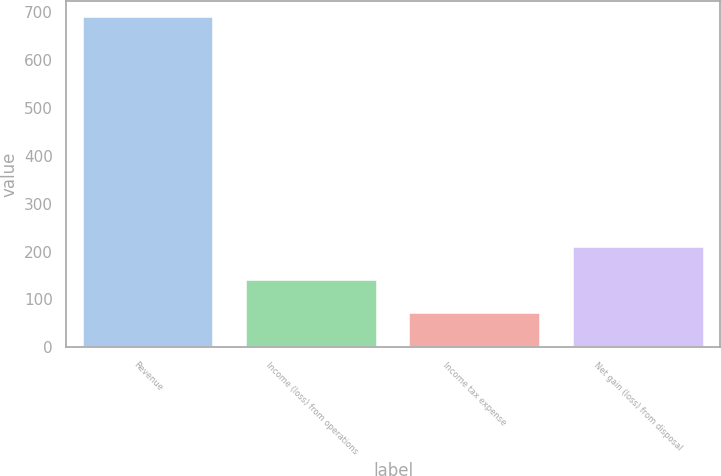Convert chart to OTSL. <chart><loc_0><loc_0><loc_500><loc_500><bar_chart><fcel>Revenue<fcel>Income (loss) from operations<fcel>Income tax expense<fcel>Net gain (loss) from disposal<nl><fcel>689<fcel>140.2<fcel>71.6<fcel>208.8<nl></chart> 